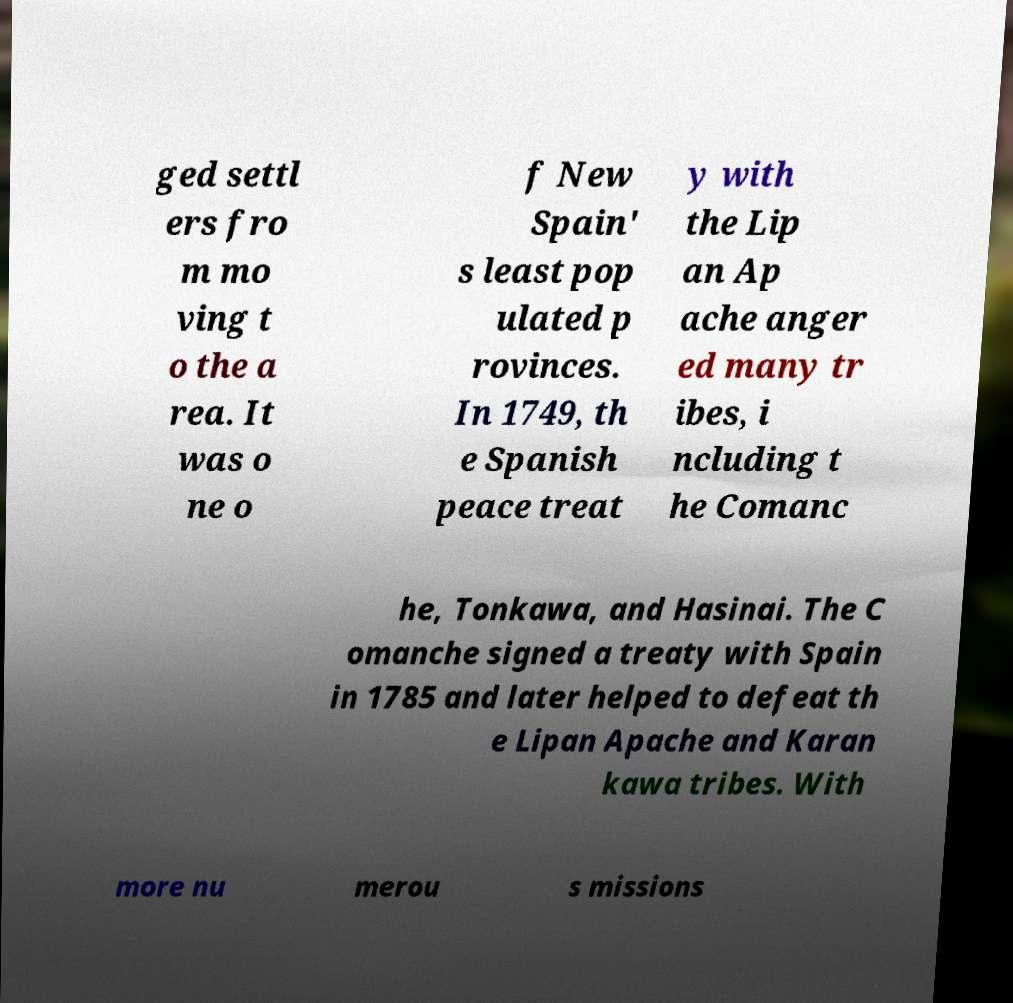I need the written content from this picture converted into text. Can you do that? ged settl ers fro m mo ving t o the a rea. It was o ne o f New Spain' s least pop ulated p rovinces. In 1749, th e Spanish peace treat y with the Lip an Ap ache anger ed many tr ibes, i ncluding t he Comanc he, Tonkawa, and Hasinai. The C omanche signed a treaty with Spain in 1785 and later helped to defeat th e Lipan Apache and Karan kawa tribes. With more nu merou s missions 